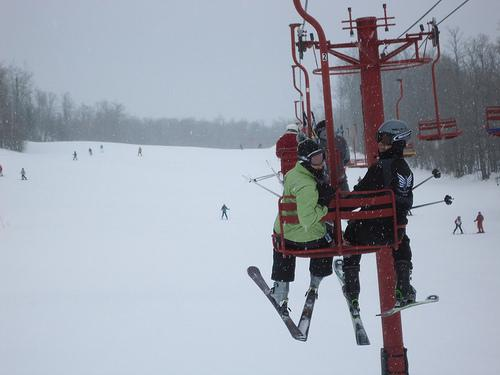Question: what is on the ground?
Choices:
A. Leaves.
B. Snow.
C. Puddles.
D. Ice.
Answer with the letter. Answer: B Question: what are the people doing?
Choices:
A. Viewing the landscape.
B. Turning around.
C. Looking backwards.
D. Seeing something.
Answer with the letter. Answer: C Question: where is the couple?
Choices:
A. Above the snow.
B. On a mountain.
C. At a resort.
D. On a ski lift.
Answer with the letter. Answer: D Question: what are the people wearing?
Choices:
A. Boots.
B. Sweaters.
C. Skis.
D. Snowboards.
Answer with the letter. Answer: C Question: where are the people?
Choices:
A. On a train.
B. On a truck.
C. On a ski lift.
D. On a boat.
Answer with the letter. Answer: C 